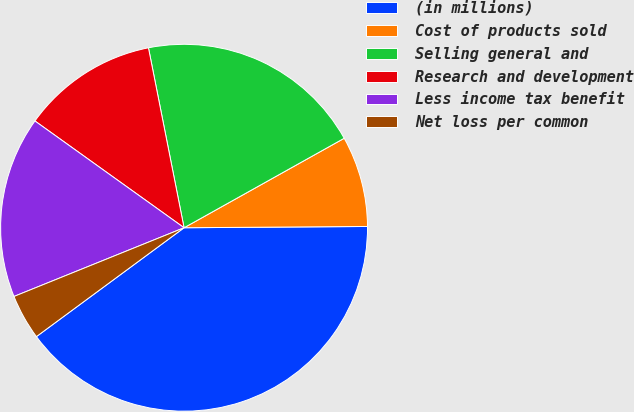<chart> <loc_0><loc_0><loc_500><loc_500><pie_chart><fcel>(in millions)<fcel>Cost of products sold<fcel>Selling general and<fcel>Research and development<fcel>Less income tax benefit<fcel>Net loss per common<nl><fcel>40.0%<fcel>8.0%<fcel>20.0%<fcel>12.0%<fcel>16.0%<fcel>4.0%<nl></chart> 